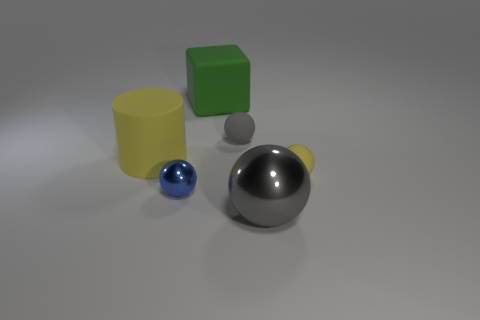What number of other objects are there of the same color as the tiny metallic ball?
Ensure brevity in your answer.  0. What number of large things are there?
Your answer should be very brief. 3. What is the gray sphere behind the shiny sphere behind the gray shiny sphere made of?
Offer a very short reply. Rubber. There is a gray sphere that is the same size as the green thing; what material is it?
Offer a very short reply. Metal. There is a ball that is in front of the blue shiny ball; is its size the same as the blue metal sphere?
Make the answer very short. No. There is a yellow matte object that is behind the small yellow thing; does it have the same shape as the big metallic thing?
Make the answer very short. No. What number of things are either big blue objects or metallic objects to the right of the blue metal thing?
Offer a terse response. 1. Are there fewer large cubes than large matte spheres?
Give a very brief answer. No. Is the number of tiny blue metallic balls greater than the number of large cyan shiny cubes?
Provide a succinct answer. Yes. How many other objects are the same material as the large yellow thing?
Make the answer very short. 3. 